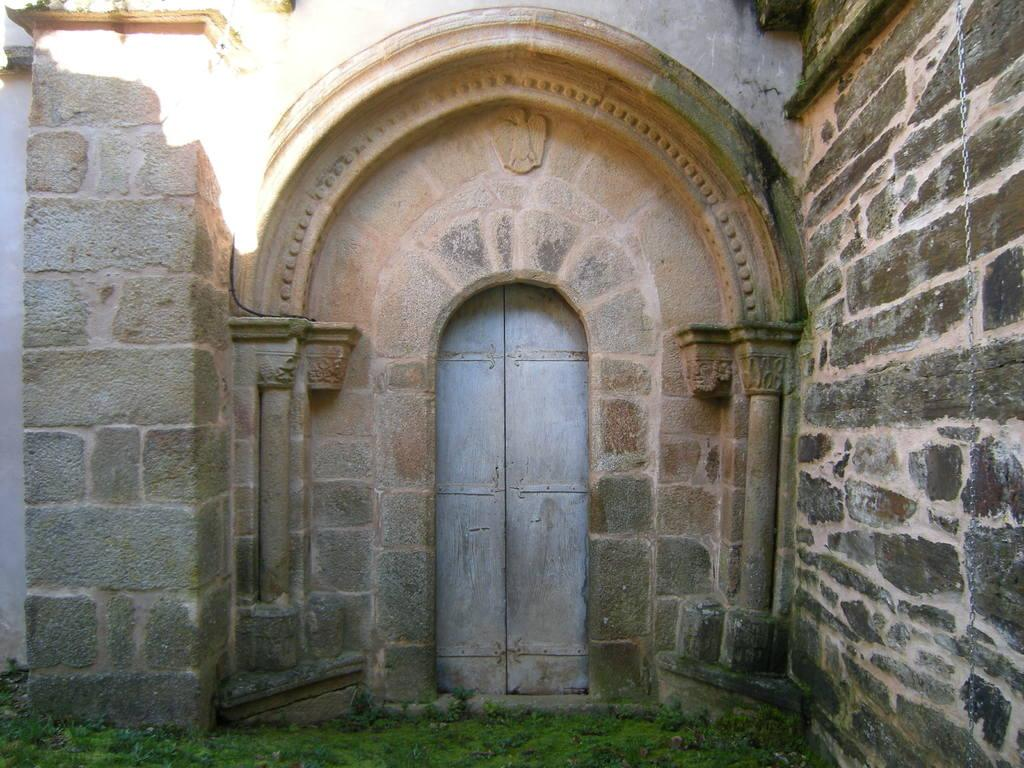What type of vegetation is present on the ground in the image? There is grass on the ground in the image. What can be seen in the background of the image? There is a wall, an arch, and doors in the background of the image. Are there any clovers growing among the grass in the image? There is no mention of clovers in the provided facts, so we cannot determine if they are present in the image. Can you see any giants in the image? There is no mention of giants in the provided facts, so we cannot determine if they are present in the image. 